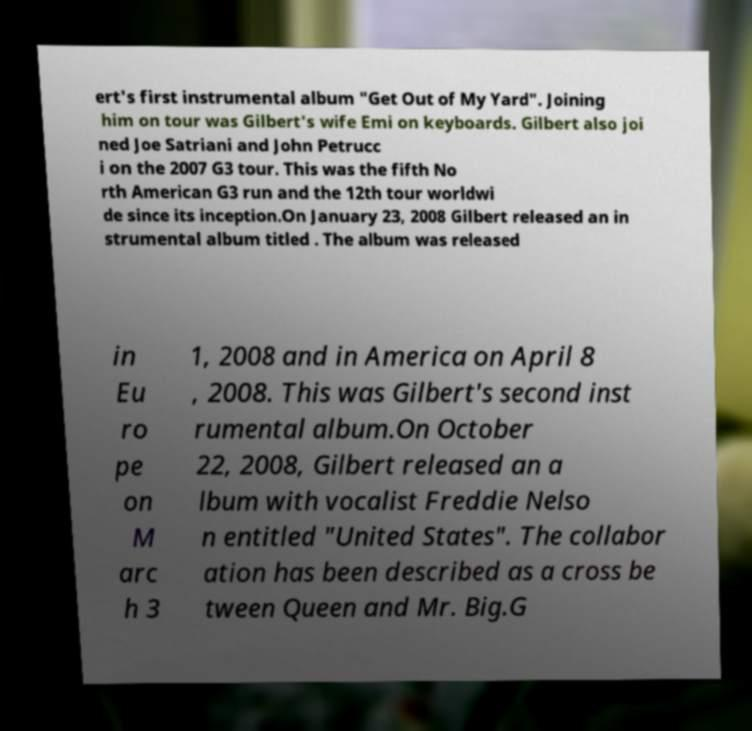Please read and relay the text visible in this image. What does it say? ert's first instrumental album "Get Out of My Yard". Joining him on tour was Gilbert's wife Emi on keyboards. Gilbert also joi ned Joe Satriani and John Petrucc i on the 2007 G3 tour. This was the fifth No rth American G3 run and the 12th tour worldwi de since its inception.On January 23, 2008 Gilbert released an in strumental album titled . The album was released in Eu ro pe on M arc h 3 1, 2008 and in America on April 8 , 2008. This was Gilbert's second inst rumental album.On October 22, 2008, Gilbert released an a lbum with vocalist Freddie Nelso n entitled "United States". The collabor ation has been described as a cross be tween Queen and Mr. Big.G 